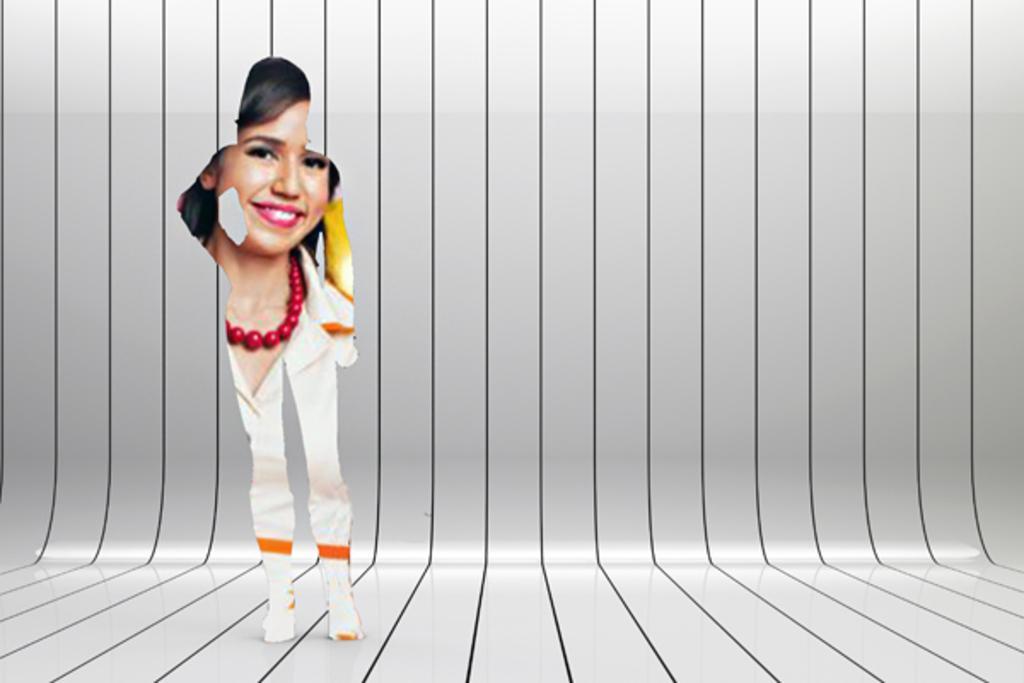In one or two sentences, can you explain what this image depicts? This is an edited image of a woman. 